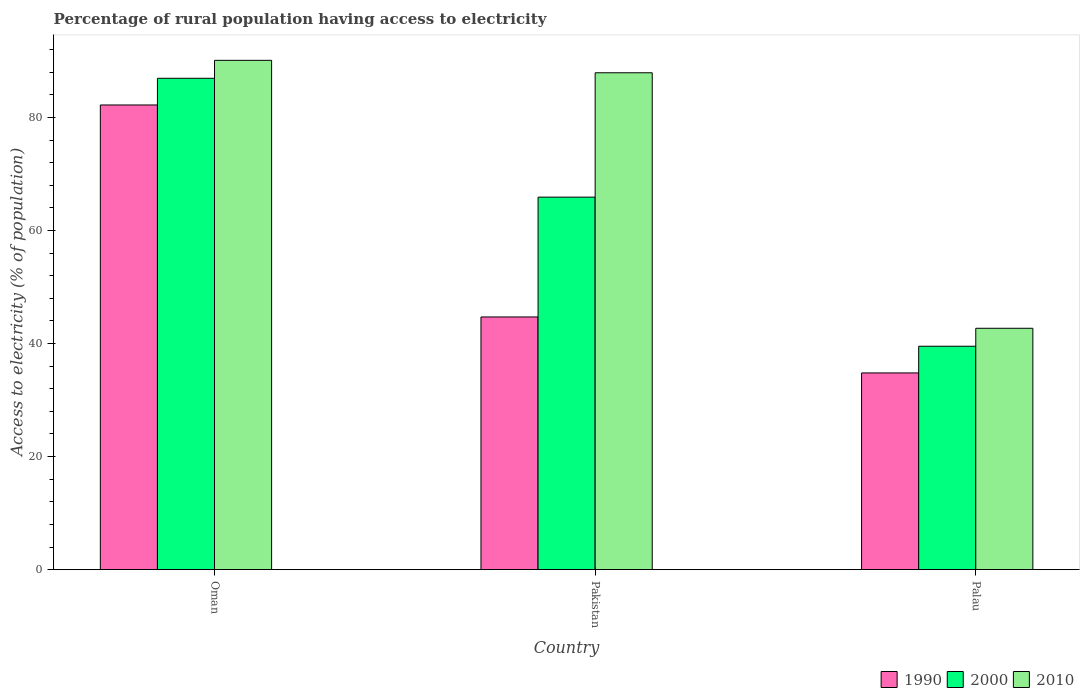How many different coloured bars are there?
Offer a terse response. 3. How many groups of bars are there?
Your answer should be compact. 3. How many bars are there on the 2nd tick from the right?
Provide a succinct answer. 3. What is the label of the 1st group of bars from the left?
Ensure brevity in your answer.  Oman. What is the percentage of rural population having access to electricity in 2010 in Pakistan?
Give a very brief answer. 87.9. Across all countries, what is the maximum percentage of rural population having access to electricity in 2010?
Your answer should be very brief. 90.1. Across all countries, what is the minimum percentage of rural population having access to electricity in 1990?
Make the answer very short. 34.8. In which country was the percentage of rural population having access to electricity in 2010 maximum?
Your answer should be very brief. Oman. In which country was the percentage of rural population having access to electricity in 1990 minimum?
Offer a terse response. Palau. What is the total percentage of rural population having access to electricity in 1990 in the graph?
Make the answer very short. 161.7. What is the difference between the percentage of rural population having access to electricity in 2000 in Oman and that in Palau?
Your response must be concise. 47.41. What is the average percentage of rural population having access to electricity in 2000 per country?
Make the answer very short. 64.12. What is the difference between the percentage of rural population having access to electricity of/in 1990 and percentage of rural population having access to electricity of/in 2000 in Pakistan?
Keep it short and to the point. -21.2. What is the ratio of the percentage of rural population having access to electricity in 1990 in Oman to that in Pakistan?
Your response must be concise. 1.84. Is the percentage of rural population having access to electricity in 2000 in Oman less than that in Pakistan?
Keep it short and to the point. No. Is the difference between the percentage of rural population having access to electricity in 1990 in Pakistan and Palau greater than the difference between the percentage of rural population having access to electricity in 2000 in Pakistan and Palau?
Provide a short and direct response. No. What is the difference between the highest and the second highest percentage of rural population having access to electricity in 2000?
Your answer should be compact. -21.03. What is the difference between the highest and the lowest percentage of rural population having access to electricity in 2000?
Your answer should be very brief. 47.41. How many bars are there?
Give a very brief answer. 9. Are the values on the major ticks of Y-axis written in scientific E-notation?
Your answer should be very brief. No. Does the graph contain any zero values?
Make the answer very short. No. Does the graph contain grids?
Give a very brief answer. No. How many legend labels are there?
Ensure brevity in your answer.  3. How are the legend labels stacked?
Your response must be concise. Horizontal. What is the title of the graph?
Make the answer very short. Percentage of rural population having access to electricity. What is the label or title of the X-axis?
Provide a short and direct response. Country. What is the label or title of the Y-axis?
Your answer should be compact. Access to electricity (% of population). What is the Access to electricity (% of population) of 1990 in Oman?
Keep it short and to the point. 82.2. What is the Access to electricity (% of population) of 2000 in Oman?
Keep it short and to the point. 86.93. What is the Access to electricity (% of population) in 2010 in Oman?
Offer a very short reply. 90.1. What is the Access to electricity (% of population) of 1990 in Pakistan?
Provide a succinct answer. 44.7. What is the Access to electricity (% of population) in 2000 in Pakistan?
Give a very brief answer. 65.9. What is the Access to electricity (% of population) of 2010 in Pakistan?
Give a very brief answer. 87.9. What is the Access to electricity (% of population) of 1990 in Palau?
Offer a very short reply. 34.8. What is the Access to electricity (% of population) in 2000 in Palau?
Provide a succinct answer. 39.52. What is the Access to electricity (% of population) of 2010 in Palau?
Offer a very short reply. 42.7. Across all countries, what is the maximum Access to electricity (% of population) of 1990?
Ensure brevity in your answer.  82.2. Across all countries, what is the maximum Access to electricity (% of population) in 2000?
Offer a very short reply. 86.93. Across all countries, what is the maximum Access to electricity (% of population) of 2010?
Provide a succinct answer. 90.1. Across all countries, what is the minimum Access to electricity (% of population) in 1990?
Offer a very short reply. 34.8. Across all countries, what is the minimum Access to electricity (% of population) in 2000?
Make the answer very short. 39.52. Across all countries, what is the minimum Access to electricity (% of population) of 2010?
Your response must be concise. 42.7. What is the total Access to electricity (% of population) of 1990 in the graph?
Offer a very short reply. 161.7. What is the total Access to electricity (% of population) in 2000 in the graph?
Offer a very short reply. 192.35. What is the total Access to electricity (% of population) of 2010 in the graph?
Provide a short and direct response. 220.7. What is the difference between the Access to electricity (% of population) of 1990 in Oman and that in Pakistan?
Offer a terse response. 37.5. What is the difference between the Access to electricity (% of population) of 2000 in Oman and that in Pakistan?
Ensure brevity in your answer.  21.03. What is the difference between the Access to electricity (% of population) of 1990 in Oman and that in Palau?
Offer a terse response. 47.41. What is the difference between the Access to electricity (% of population) of 2000 in Oman and that in Palau?
Offer a terse response. 47.41. What is the difference between the Access to electricity (% of population) in 2010 in Oman and that in Palau?
Your answer should be compact. 47.4. What is the difference between the Access to electricity (% of population) of 1990 in Pakistan and that in Palau?
Provide a succinct answer. 9.9. What is the difference between the Access to electricity (% of population) in 2000 in Pakistan and that in Palau?
Provide a short and direct response. 26.38. What is the difference between the Access to electricity (% of population) of 2010 in Pakistan and that in Palau?
Offer a very short reply. 45.2. What is the difference between the Access to electricity (% of population) in 1990 in Oman and the Access to electricity (% of population) in 2000 in Pakistan?
Offer a very short reply. 16.3. What is the difference between the Access to electricity (% of population) of 1990 in Oman and the Access to electricity (% of population) of 2010 in Pakistan?
Your response must be concise. -5.7. What is the difference between the Access to electricity (% of population) of 2000 in Oman and the Access to electricity (% of population) of 2010 in Pakistan?
Provide a short and direct response. -0.97. What is the difference between the Access to electricity (% of population) in 1990 in Oman and the Access to electricity (% of population) in 2000 in Palau?
Give a very brief answer. 42.68. What is the difference between the Access to electricity (% of population) in 1990 in Oman and the Access to electricity (% of population) in 2010 in Palau?
Give a very brief answer. 39.5. What is the difference between the Access to electricity (% of population) in 2000 in Oman and the Access to electricity (% of population) in 2010 in Palau?
Your response must be concise. 44.23. What is the difference between the Access to electricity (% of population) in 1990 in Pakistan and the Access to electricity (% of population) in 2000 in Palau?
Your answer should be very brief. 5.18. What is the difference between the Access to electricity (% of population) of 1990 in Pakistan and the Access to electricity (% of population) of 2010 in Palau?
Give a very brief answer. 2. What is the difference between the Access to electricity (% of population) in 2000 in Pakistan and the Access to electricity (% of population) in 2010 in Palau?
Provide a succinct answer. 23.2. What is the average Access to electricity (% of population) of 1990 per country?
Keep it short and to the point. 53.9. What is the average Access to electricity (% of population) of 2000 per country?
Offer a terse response. 64.12. What is the average Access to electricity (% of population) of 2010 per country?
Keep it short and to the point. 73.57. What is the difference between the Access to electricity (% of population) of 1990 and Access to electricity (% of population) of 2000 in Oman?
Offer a very short reply. -4.72. What is the difference between the Access to electricity (% of population) in 1990 and Access to electricity (% of population) in 2010 in Oman?
Your answer should be very brief. -7.9. What is the difference between the Access to electricity (% of population) of 2000 and Access to electricity (% of population) of 2010 in Oman?
Provide a succinct answer. -3.17. What is the difference between the Access to electricity (% of population) of 1990 and Access to electricity (% of population) of 2000 in Pakistan?
Ensure brevity in your answer.  -21.2. What is the difference between the Access to electricity (% of population) of 1990 and Access to electricity (% of population) of 2010 in Pakistan?
Ensure brevity in your answer.  -43.2. What is the difference between the Access to electricity (% of population) of 2000 and Access to electricity (% of population) of 2010 in Pakistan?
Provide a short and direct response. -22. What is the difference between the Access to electricity (% of population) of 1990 and Access to electricity (% of population) of 2000 in Palau?
Ensure brevity in your answer.  -4.72. What is the difference between the Access to electricity (% of population) of 1990 and Access to electricity (% of population) of 2010 in Palau?
Ensure brevity in your answer.  -7.9. What is the difference between the Access to electricity (% of population) in 2000 and Access to electricity (% of population) in 2010 in Palau?
Make the answer very short. -3.18. What is the ratio of the Access to electricity (% of population) of 1990 in Oman to that in Pakistan?
Your response must be concise. 1.84. What is the ratio of the Access to electricity (% of population) in 2000 in Oman to that in Pakistan?
Provide a short and direct response. 1.32. What is the ratio of the Access to electricity (% of population) of 2010 in Oman to that in Pakistan?
Provide a short and direct response. 1.02. What is the ratio of the Access to electricity (% of population) in 1990 in Oman to that in Palau?
Keep it short and to the point. 2.36. What is the ratio of the Access to electricity (% of population) of 2000 in Oman to that in Palau?
Provide a succinct answer. 2.2. What is the ratio of the Access to electricity (% of population) in 2010 in Oman to that in Palau?
Give a very brief answer. 2.11. What is the ratio of the Access to electricity (% of population) in 1990 in Pakistan to that in Palau?
Keep it short and to the point. 1.28. What is the ratio of the Access to electricity (% of population) in 2000 in Pakistan to that in Palau?
Give a very brief answer. 1.67. What is the ratio of the Access to electricity (% of population) of 2010 in Pakistan to that in Palau?
Your answer should be compact. 2.06. What is the difference between the highest and the second highest Access to electricity (% of population) of 1990?
Keep it short and to the point. 37.5. What is the difference between the highest and the second highest Access to electricity (% of population) of 2000?
Provide a short and direct response. 21.03. What is the difference between the highest and the second highest Access to electricity (% of population) of 2010?
Provide a short and direct response. 2.2. What is the difference between the highest and the lowest Access to electricity (% of population) in 1990?
Provide a succinct answer. 47.41. What is the difference between the highest and the lowest Access to electricity (% of population) in 2000?
Your response must be concise. 47.41. What is the difference between the highest and the lowest Access to electricity (% of population) in 2010?
Your response must be concise. 47.4. 